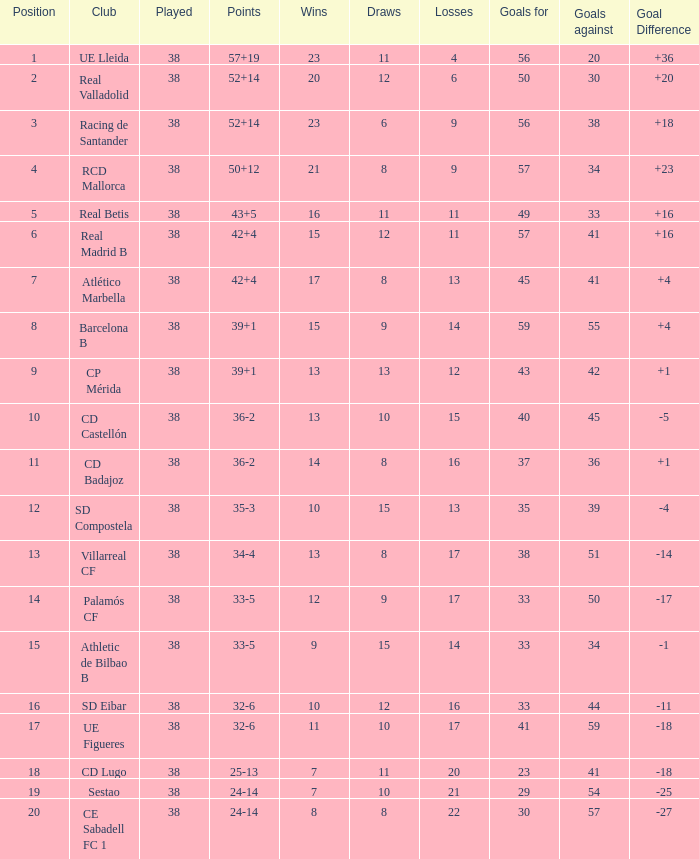What is the highest number of wins with a goal difference less than 4 at the Villarreal CF and more than 38 played? None. 